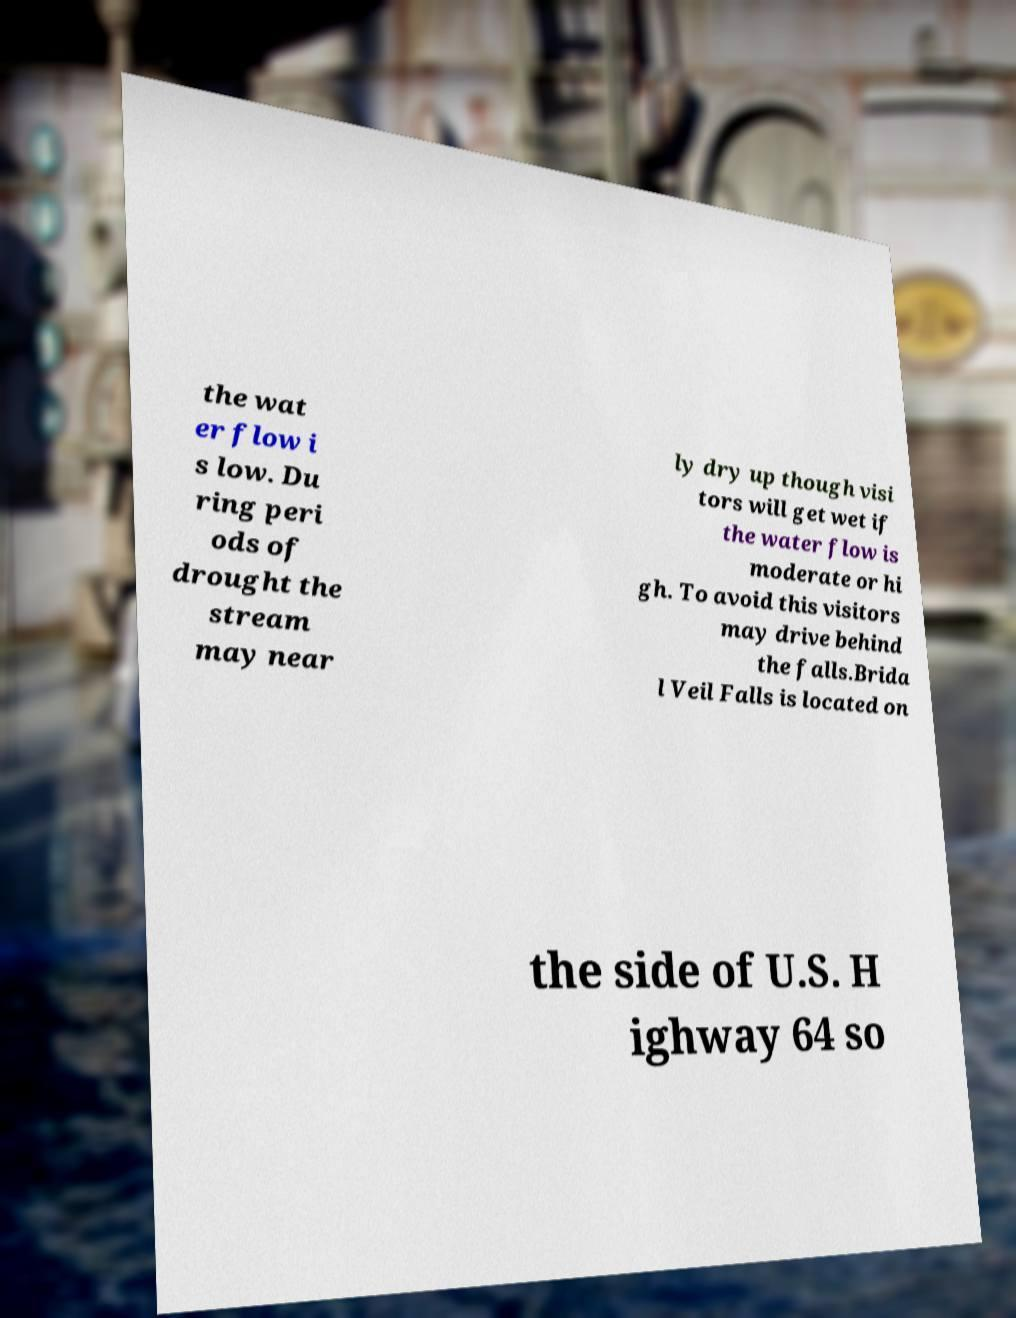Please read and relay the text visible in this image. What does it say? the wat er flow i s low. Du ring peri ods of drought the stream may near ly dry up though visi tors will get wet if the water flow is moderate or hi gh. To avoid this visitors may drive behind the falls.Brida l Veil Falls is located on the side of U.S. H ighway 64 so 